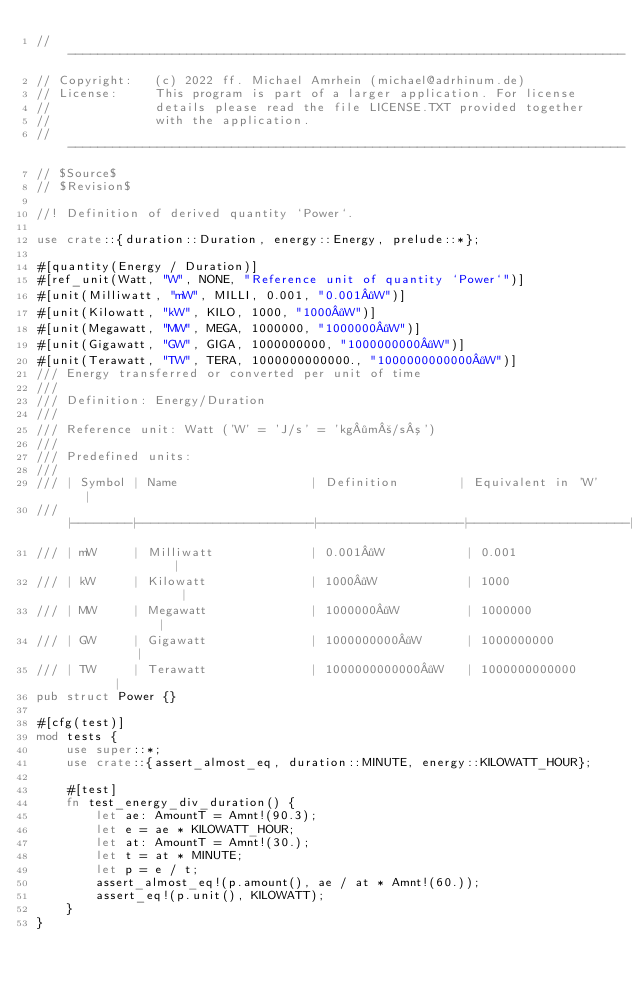Convert code to text. <code><loc_0><loc_0><loc_500><loc_500><_Rust_>// ---------------------------------------------------------------------------
// Copyright:   (c) 2022 ff. Michael Amrhein (michael@adrhinum.de)
// License:     This program is part of a larger application. For license
//              details please read the file LICENSE.TXT provided together
//              with the application.
// ---------------------------------------------------------------------------
// $Source$
// $Revision$

//! Definition of derived quantity `Power`.

use crate::{duration::Duration, energy::Energy, prelude::*};

#[quantity(Energy / Duration)]
#[ref_unit(Watt, "W", NONE, "Reference unit of quantity `Power`")]
#[unit(Milliwatt, "mW", MILLI, 0.001, "0.001·W")]
#[unit(Kilowatt, "kW", KILO, 1000, "1000·W")]
#[unit(Megawatt, "MW", MEGA, 1000000, "1000000·W")]
#[unit(Gigawatt, "GW", GIGA, 1000000000, "1000000000·W")]
#[unit(Terawatt, "TW", TERA, 1000000000000., "1000000000000·W")]
/// Energy transferred or converted per unit of time
///
/// Definition: Energy/Duration
///
/// Reference unit: Watt ('W' = 'J/s' = 'kg·m²/s³')
///
/// Predefined units:
///
/// | Symbol | Name                  | Definition        | Equivalent in 'W'   |
/// |--------|-----------------------|-------------------|---------------------|
/// | mW     | Milliwatt             | 0.001·W           | 0.001               |
/// | kW     | Kilowatt              | 1000·W            | 1000                |
/// | MW     | Megawatt              | 1000000·W         | 1000000             |
/// | GW     | Gigawatt              | 1000000000·W      | 1000000000          |
/// | TW     | Terawatt              | 1000000000000·W   | 1000000000000       |
pub struct Power {}

#[cfg(test)]
mod tests {
    use super::*;
    use crate::{assert_almost_eq, duration::MINUTE, energy::KILOWATT_HOUR};

    #[test]
    fn test_energy_div_duration() {
        let ae: AmountT = Amnt!(90.3);
        let e = ae * KILOWATT_HOUR;
        let at: AmountT = Amnt!(30.);
        let t = at * MINUTE;
        let p = e / t;
        assert_almost_eq!(p.amount(), ae / at * Amnt!(60.));
        assert_eq!(p.unit(), KILOWATT);
    }
}
</code> 